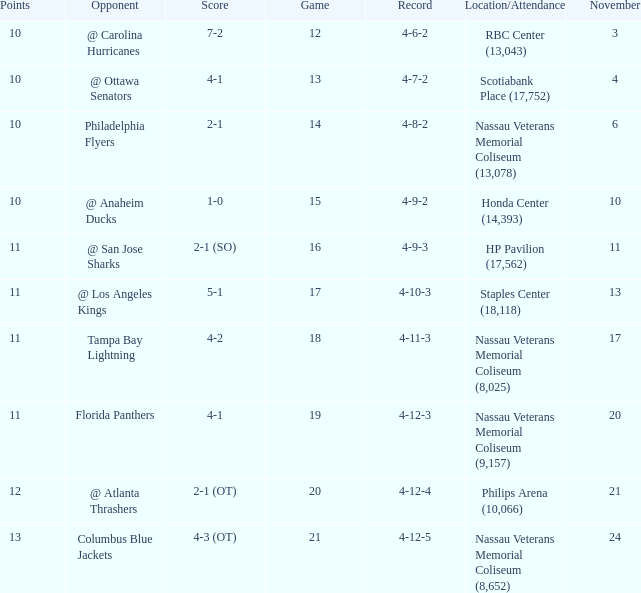What is the highest entry in November for the game 20? 21.0. 